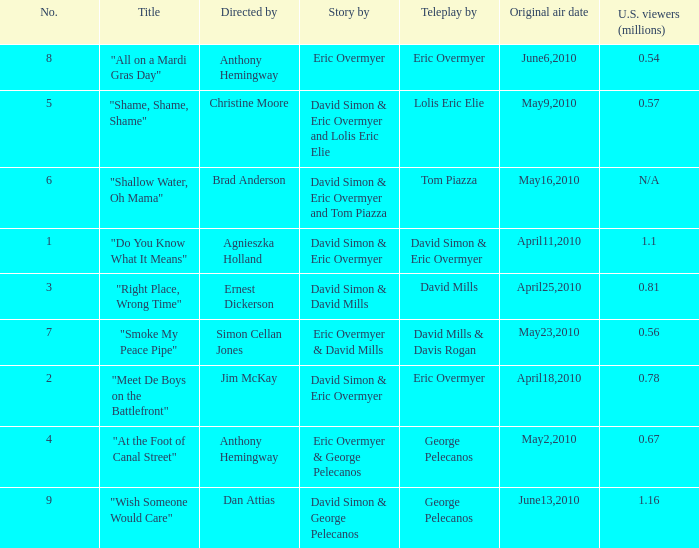Name the number for simon cellan jones 7.0. 